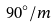<formula> <loc_0><loc_0><loc_500><loc_500>9 0 ^ { \circ } / m</formula> 